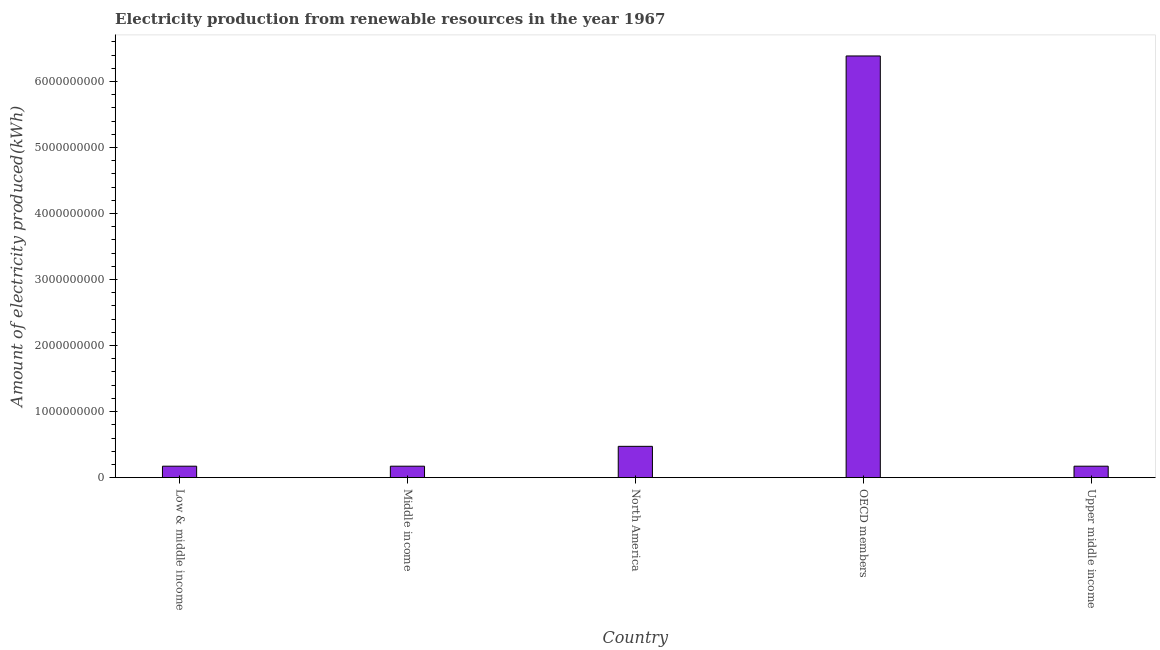Does the graph contain any zero values?
Your answer should be very brief. No. What is the title of the graph?
Ensure brevity in your answer.  Electricity production from renewable resources in the year 1967. What is the label or title of the Y-axis?
Provide a short and direct response. Amount of electricity produced(kWh). What is the amount of electricity produced in Upper middle income?
Keep it short and to the point. 1.73e+08. Across all countries, what is the maximum amount of electricity produced?
Make the answer very short. 6.39e+09. Across all countries, what is the minimum amount of electricity produced?
Your response must be concise. 1.73e+08. What is the sum of the amount of electricity produced?
Make the answer very short. 7.38e+09. What is the difference between the amount of electricity produced in OECD members and Upper middle income?
Provide a succinct answer. 6.21e+09. What is the average amount of electricity produced per country?
Keep it short and to the point. 1.48e+09. What is the median amount of electricity produced?
Offer a terse response. 1.73e+08. What is the ratio of the amount of electricity produced in OECD members to that in Upper middle income?
Provide a short and direct response. 36.92. Is the amount of electricity produced in Low & middle income less than that in OECD members?
Give a very brief answer. Yes. Is the difference between the amount of electricity produced in Low & middle income and OECD members greater than the difference between any two countries?
Offer a very short reply. Yes. What is the difference between the highest and the second highest amount of electricity produced?
Provide a succinct answer. 5.91e+09. Is the sum of the amount of electricity produced in Low & middle income and North America greater than the maximum amount of electricity produced across all countries?
Give a very brief answer. No. What is the difference between the highest and the lowest amount of electricity produced?
Your answer should be compact. 6.21e+09. Are all the bars in the graph horizontal?
Provide a short and direct response. No. How many countries are there in the graph?
Your answer should be very brief. 5. What is the difference between two consecutive major ticks on the Y-axis?
Offer a very short reply. 1.00e+09. What is the Amount of electricity produced(kWh) in Low & middle income?
Offer a very short reply. 1.73e+08. What is the Amount of electricity produced(kWh) in Middle income?
Offer a terse response. 1.73e+08. What is the Amount of electricity produced(kWh) in North America?
Ensure brevity in your answer.  4.74e+08. What is the Amount of electricity produced(kWh) of OECD members?
Your response must be concise. 6.39e+09. What is the Amount of electricity produced(kWh) of Upper middle income?
Give a very brief answer. 1.73e+08. What is the difference between the Amount of electricity produced(kWh) in Low & middle income and Middle income?
Ensure brevity in your answer.  0. What is the difference between the Amount of electricity produced(kWh) in Low & middle income and North America?
Ensure brevity in your answer.  -3.01e+08. What is the difference between the Amount of electricity produced(kWh) in Low & middle income and OECD members?
Ensure brevity in your answer.  -6.21e+09. What is the difference between the Amount of electricity produced(kWh) in Low & middle income and Upper middle income?
Ensure brevity in your answer.  0. What is the difference between the Amount of electricity produced(kWh) in Middle income and North America?
Provide a succinct answer. -3.01e+08. What is the difference between the Amount of electricity produced(kWh) in Middle income and OECD members?
Ensure brevity in your answer.  -6.21e+09. What is the difference between the Amount of electricity produced(kWh) in Middle income and Upper middle income?
Your answer should be compact. 0. What is the difference between the Amount of electricity produced(kWh) in North America and OECD members?
Give a very brief answer. -5.91e+09. What is the difference between the Amount of electricity produced(kWh) in North America and Upper middle income?
Give a very brief answer. 3.01e+08. What is the difference between the Amount of electricity produced(kWh) in OECD members and Upper middle income?
Offer a terse response. 6.21e+09. What is the ratio of the Amount of electricity produced(kWh) in Low & middle income to that in Middle income?
Your answer should be very brief. 1. What is the ratio of the Amount of electricity produced(kWh) in Low & middle income to that in North America?
Give a very brief answer. 0.36. What is the ratio of the Amount of electricity produced(kWh) in Low & middle income to that in OECD members?
Make the answer very short. 0.03. What is the ratio of the Amount of electricity produced(kWh) in Middle income to that in North America?
Your answer should be very brief. 0.36. What is the ratio of the Amount of electricity produced(kWh) in Middle income to that in OECD members?
Give a very brief answer. 0.03. What is the ratio of the Amount of electricity produced(kWh) in North America to that in OECD members?
Your answer should be very brief. 0.07. What is the ratio of the Amount of electricity produced(kWh) in North America to that in Upper middle income?
Keep it short and to the point. 2.74. What is the ratio of the Amount of electricity produced(kWh) in OECD members to that in Upper middle income?
Your answer should be very brief. 36.92. 